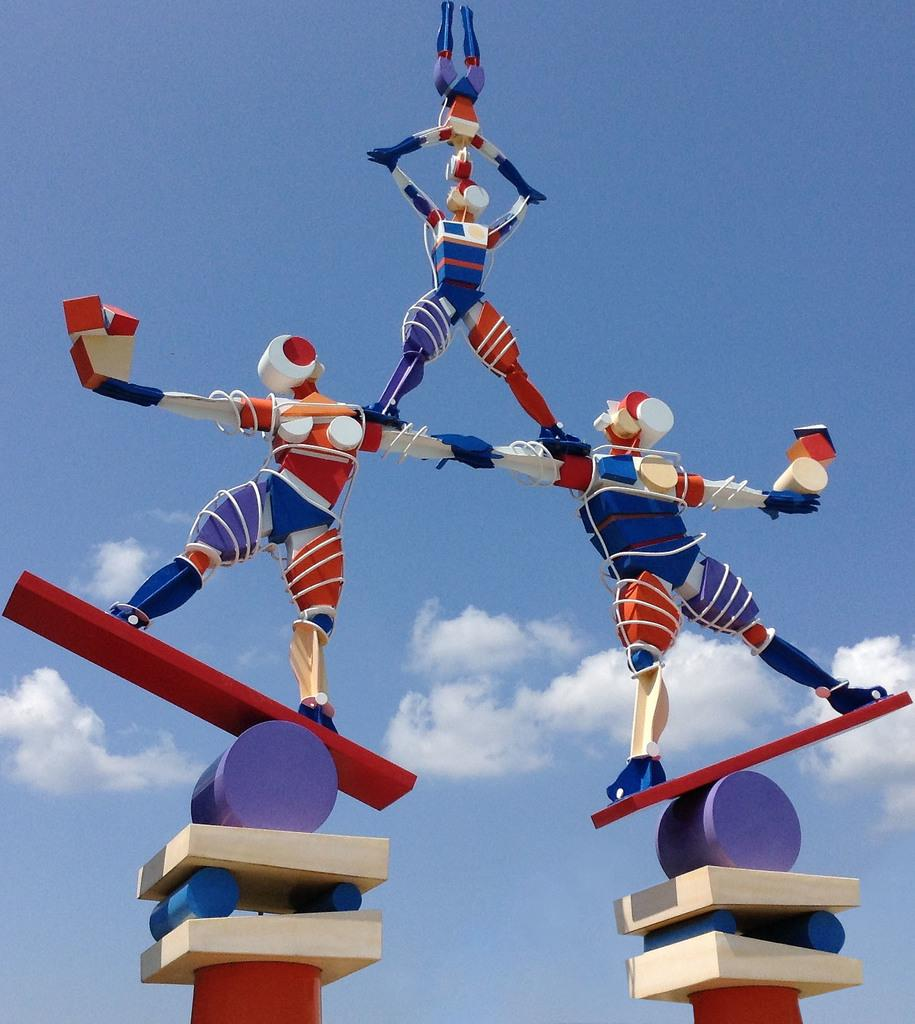What type of objects are in the image? There are toy human beings in the image. How are the toy human beings positioned? The toy human beings are on blocks. What can be seen in the background of the image? There is sky visible in the background of the image. What is present in the sky? Clouds are present in the sky. What type of reward is the woman holding for the toy human beings in the image? There is no woman present in the image, and therefore no reward can be observed. What type of yarn is being used by the toy human beings to knit in the image? There is no yarn or knitting activity present in the image. 